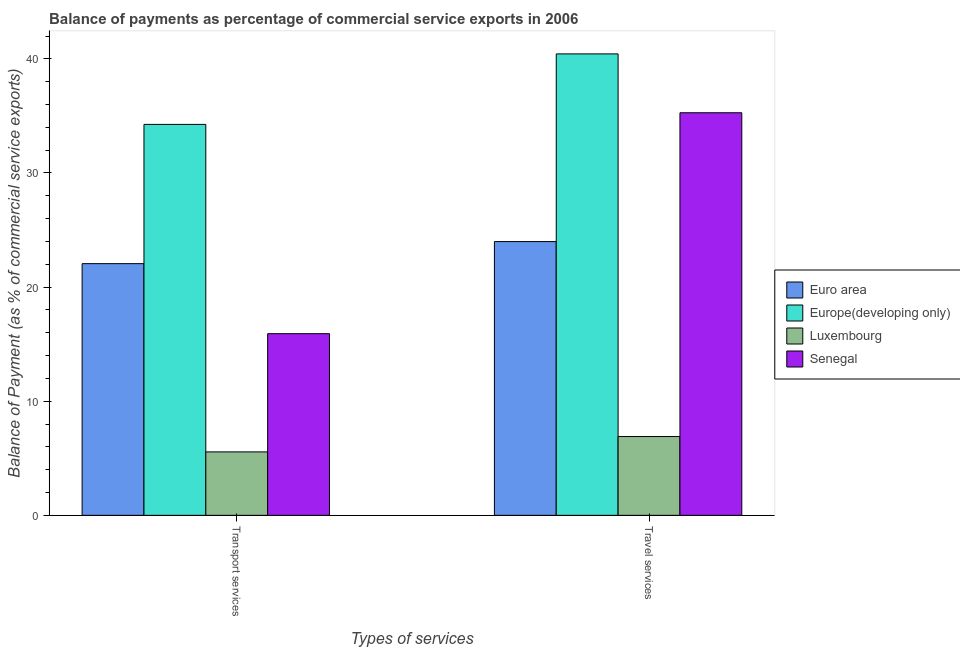How many groups of bars are there?
Provide a short and direct response. 2. Are the number of bars per tick equal to the number of legend labels?
Make the answer very short. Yes. Are the number of bars on each tick of the X-axis equal?
Provide a succinct answer. Yes. How many bars are there on the 2nd tick from the left?
Ensure brevity in your answer.  4. What is the label of the 2nd group of bars from the left?
Ensure brevity in your answer.  Travel services. What is the balance of payments of transport services in Europe(developing only)?
Your answer should be compact. 34.26. Across all countries, what is the maximum balance of payments of travel services?
Your answer should be very brief. 40.43. Across all countries, what is the minimum balance of payments of transport services?
Provide a succinct answer. 5.56. In which country was the balance of payments of transport services maximum?
Your answer should be very brief. Europe(developing only). In which country was the balance of payments of travel services minimum?
Provide a succinct answer. Luxembourg. What is the total balance of payments of travel services in the graph?
Keep it short and to the point. 106.6. What is the difference between the balance of payments of travel services in Europe(developing only) and that in Senegal?
Offer a very short reply. 5.16. What is the difference between the balance of payments of transport services in Euro area and the balance of payments of travel services in Luxembourg?
Provide a succinct answer. 15.15. What is the average balance of payments of transport services per country?
Give a very brief answer. 19.45. What is the difference between the balance of payments of transport services and balance of payments of travel services in Senegal?
Provide a succinct answer. -19.36. What is the ratio of the balance of payments of transport services in Senegal to that in Europe(developing only)?
Offer a terse response. 0.46. In how many countries, is the balance of payments of transport services greater than the average balance of payments of transport services taken over all countries?
Offer a terse response. 2. What does the 1st bar from the left in Travel services represents?
Keep it short and to the point. Euro area. What does the 3rd bar from the right in Travel services represents?
Give a very brief answer. Europe(developing only). Are all the bars in the graph horizontal?
Your answer should be compact. No. What is the difference between two consecutive major ticks on the Y-axis?
Provide a short and direct response. 10. Are the values on the major ticks of Y-axis written in scientific E-notation?
Make the answer very short. No. Does the graph contain grids?
Make the answer very short. No. Where does the legend appear in the graph?
Keep it short and to the point. Center right. How many legend labels are there?
Your answer should be compact. 4. What is the title of the graph?
Offer a very short reply. Balance of payments as percentage of commercial service exports in 2006. Does "Yemen, Rep." appear as one of the legend labels in the graph?
Make the answer very short. No. What is the label or title of the X-axis?
Offer a very short reply. Types of services. What is the label or title of the Y-axis?
Ensure brevity in your answer.  Balance of Payment (as % of commercial service exports). What is the Balance of Payment (as % of commercial service exports) in Euro area in Transport services?
Make the answer very short. 22.06. What is the Balance of Payment (as % of commercial service exports) of Europe(developing only) in Transport services?
Your answer should be very brief. 34.26. What is the Balance of Payment (as % of commercial service exports) in Luxembourg in Transport services?
Make the answer very short. 5.56. What is the Balance of Payment (as % of commercial service exports) in Senegal in Transport services?
Offer a terse response. 15.92. What is the Balance of Payment (as % of commercial service exports) of Euro area in Travel services?
Offer a terse response. 23.99. What is the Balance of Payment (as % of commercial service exports) in Europe(developing only) in Travel services?
Provide a succinct answer. 40.43. What is the Balance of Payment (as % of commercial service exports) of Luxembourg in Travel services?
Give a very brief answer. 6.91. What is the Balance of Payment (as % of commercial service exports) of Senegal in Travel services?
Offer a very short reply. 35.28. Across all Types of services, what is the maximum Balance of Payment (as % of commercial service exports) of Euro area?
Offer a terse response. 23.99. Across all Types of services, what is the maximum Balance of Payment (as % of commercial service exports) in Europe(developing only)?
Provide a succinct answer. 40.43. Across all Types of services, what is the maximum Balance of Payment (as % of commercial service exports) in Luxembourg?
Offer a very short reply. 6.91. Across all Types of services, what is the maximum Balance of Payment (as % of commercial service exports) in Senegal?
Make the answer very short. 35.28. Across all Types of services, what is the minimum Balance of Payment (as % of commercial service exports) in Euro area?
Your answer should be compact. 22.06. Across all Types of services, what is the minimum Balance of Payment (as % of commercial service exports) in Europe(developing only)?
Your answer should be very brief. 34.26. Across all Types of services, what is the minimum Balance of Payment (as % of commercial service exports) in Luxembourg?
Your answer should be very brief. 5.56. Across all Types of services, what is the minimum Balance of Payment (as % of commercial service exports) in Senegal?
Make the answer very short. 15.92. What is the total Balance of Payment (as % of commercial service exports) in Euro area in the graph?
Your response must be concise. 46.04. What is the total Balance of Payment (as % of commercial service exports) in Europe(developing only) in the graph?
Your answer should be compact. 74.69. What is the total Balance of Payment (as % of commercial service exports) of Luxembourg in the graph?
Your response must be concise. 12.46. What is the total Balance of Payment (as % of commercial service exports) of Senegal in the graph?
Your answer should be very brief. 51.2. What is the difference between the Balance of Payment (as % of commercial service exports) in Euro area in Transport services and that in Travel services?
Provide a short and direct response. -1.93. What is the difference between the Balance of Payment (as % of commercial service exports) of Europe(developing only) in Transport services and that in Travel services?
Keep it short and to the point. -6.18. What is the difference between the Balance of Payment (as % of commercial service exports) in Luxembourg in Transport services and that in Travel services?
Provide a succinct answer. -1.35. What is the difference between the Balance of Payment (as % of commercial service exports) of Senegal in Transport services and that in Travel services?
Keep it short and to the point. -19.36. What is the difference between the Balance of Payment (as % of commercial service exports) of Euro area in Transport services and the Balance of Payment (as % of commercial service exports) of Europe(developing only) in Travel services?
Ensure brevity in your answer.  -18.38. What is the difference between the Balance of Payment (as % of commercial service exports) in Euro area in Transport services and the Balance of Payment (as % of commercial service exports) in Luxembourg in Travel services?
Your answer should be compact. 15.15. What is the difference between the Balance of Payment (as % of commercial service exports) in Euro area in Transport services and the Balance of Payment (as % of commercial service exports) in Senegal in Travel services?
Offer a very short reply. -13.22. What is the difference between the Balance of Payment (as % of commercial service exports) of Europe(developing only) in Transport services and the Balance of Payment (as % of commercial service exports) of Luxembourg in Travel services?
Your answer should be compact. 27.35. What is the difference between the Balance of Payment (as % of commercial service exports) of Europe(developing only) in Transport services and the Balance of Payment (as % of commercial service exports) of Senegal in Travel services?
Your response must be concise. -1.02. What is the difference between the Balance of Payment (as % of commercial service exports) of Luxembourg in Transport services and the Balance of Payment (as % of commercial service exports) of Senegal in Travel services?
Make the answer very short. -29.72. What is the average Balance of Payment (as % of commercial service exports) in Euro area per Types of services?
Give a very brief answer. 23.02. What is the average Balance of Payment (as % of commercial service exports) of Europe(developing only) per Types of services?
Provide a short and direct response. 37.35. What is the average Balance of Payment (as % of commercial service exports) of Luxembourg per Types of services?
Provide a short and direct response. 6.23. What is the average Balance of Payment (as % of commercial service exports) in Senegal per Types of services?
Provide a short and direct response. 25.6. What is the difference between the Balance of Payment (as % of commercial service exports) of Euro area and Balance of Payment (as % of commercial service exports) of Europe(developing only) in Transport services?
Your response must be concise. -12.2. What is the difference between the Balance of Payment (as % of commercial service exports) of Euro area and Balance of Payment (as % of commercial service exports) of Luxembourg in Transport services?
Ensure brevity in your answer.  16.5. What is the difference between the Balance of Payment (as % of commercial service exports) in Euro area and Balance of Payment (as % of commercial service exports) in Senegal in Transport services?
Your response must be concise. 6.14. What is the difference between the Balance of Payment (as % of commercial service exports) in Europe(developing only) and Balance of Payment (as % of commercial service exports) in Luxembourg in Transport services?
Keep it short and to the point. 28.7. What is the difference between the Balance of Payment (as % of commercial service exports) of Europe(developing only) and Balance of Payment (as % of commercial service exports) of Senegal in Transport services?
Offer a terse response. 18.34. What is the difference between the Balance of Payment (as % of commercial service exports) in Luxembourg and Balance of Payment (as % of commercial service exports) in Senegal in Transport services?
Ensure brevity in your answer.  -10.36. What is the difference between the Balance of Payment (as % of commercial service exports) of Euro area and Balance of Payment (as % of commercial service exports) of Europe(developing only) in Travel services?
Provide a succinct answer. -16.45. What is the difference between the Balance of Payment (as % of commercial service exports) of Euro area and Balance of Payment (as % of commercial service exports) of Luxembourg in Travel services?
Keep it short and to the point. 17.08. What is the difference between the Balance of Payment (as % of commercial service exports) of Euro area and Balance of Payment (as % of commercial service exports) of Senegal in Travel services?
Your answer should be very brief. -11.29. What is the difference between the Balance of Payment (as % of commercial service exports) of Europe(developing only) and Balance of Payment (as % of commercial service exports) of Luxembourg in Travel services?
Ensure brevity in your answer.  33.53. What is the difference between the Balance of Payment (as % of commercial service exports) of Europe(developing only) and Balance of Payment (as % of commercial service exports) of Senegal in Travel services?
Provide a short and direct response. 5.16. What is the difference between the Balance of Payment (as % of commercial service exports) in Luxembourg and Balance of Payment (as % of commercial service exports) in Senegal in Travel services?
Make the answer very short. -28.37. What is the ratio of the Balance of Payment (as % of commercial service exports) in Euro area in Transport services to that in Travel services?
Give a very brief answer. 0.92. What is the ratio of the Balance of Payment (as % of commercial service exports) in Europe(developing only) in Transport services to that in Travel services?
Offer a very short reply. 0.85. What is the ratio of the Balance of Payment (as % of commercial service exports) of Luxembourg in Transport services to that in Travel services?
Your response must be concise. 0.81. What is the ratio of the Balance of Payment (as % of commercial service exports) in Senegal in Transport services to that in Travel services?
Your answer should be compact. 0.45. What is the difference between the highest and the second highest Balance of Payment (as % of commercial service exports) of Euro area?
Ensure brevity in your answer.  1.93. What is the difference between the highest and the second highest Balance of Payment (as % of commercial service exports) of Europe(developing only)?
Your answer should be compact. 6.18. What is the difference between the highest and the second highest Balance of Payment (as % of commercial service exports) of Luxembourg?
Provide a succinct answer. 1.35. What is the difference between the highest and the second highest Balance of Payment (as % of commercial service exports) of Senegal?
Provide a short and direct response. 19.36. What is the difference between the highest and the lowest Balance of Payment (as % of commercial service exports) in Euro area?
Keep it short and to the point. 1.93. What is the difference between the highest and the lowest Balance of Payment (as % of commercial service exports) in Europe(developing only)?
Make the answer very short. 6.18. What is the difference between the highest and the lowest Balance of Payment (as % of commercial service exports) of Luxembourg?
Provide a succinct answer. 1.35. What is the difference between the highest and the lowest Balance of Payment (as % of commercial service exports) in Senegal?
Make the answer very short. 19.36. 